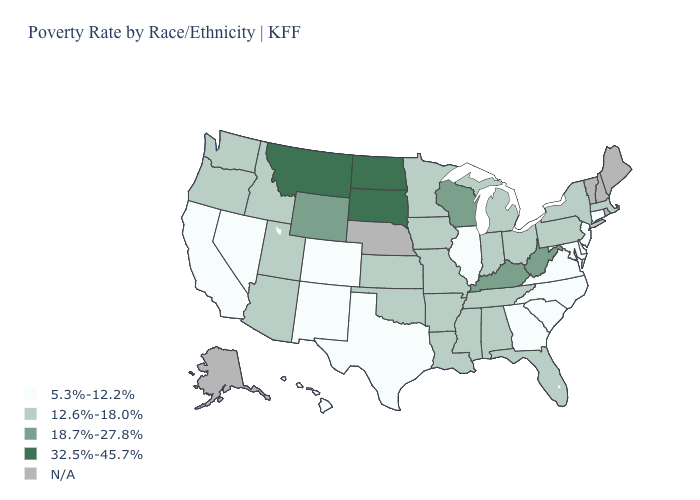Does the map have missing data?
Give a very brief answer. Yes. What is the value of Louisiana?
Quick response, please. 12.6%-18.0%. How many symbols are there in the legend?
Short answer required. 5. Does Montana have the highest value in the West?
Short answer required. Yes. Which states hav the highest value in the West?
Keep it brief. Montana. What is the highest value in states that border Delaware?
Write a very short answer. 12.6%-18.0%. Which states hav the highest value in the West?
Be succinct. Montana. Name the states that have a value in the range 5.3%-12.2%?
Write a very short answer. California, Colorado, Connecticut, Delaware, Georgia, Hawaii, Illinois, Maryland, Nevada, New Jersey, New Mexico, North Carolina, South Carolina, Texas, Virginia. What is the value of New York?
Quick response, please. 12.6%-18.0%. What is the value of Connecticut?
Short answer required. 5.3%-12.2%. Among the states that border North Carolina , does Tennessee have the highest value?
Short answer required. Yes. Does the map have missing data?
Write a very short answer. Yes. What is the value of Montana?
Short answer required. 32.5%-45.7%. Does the first symbol in the legend represent the smallest category?
Quick response, please. Yes. What is the value of Michigan?
Answer briefly. 12.6%-18.0%. 